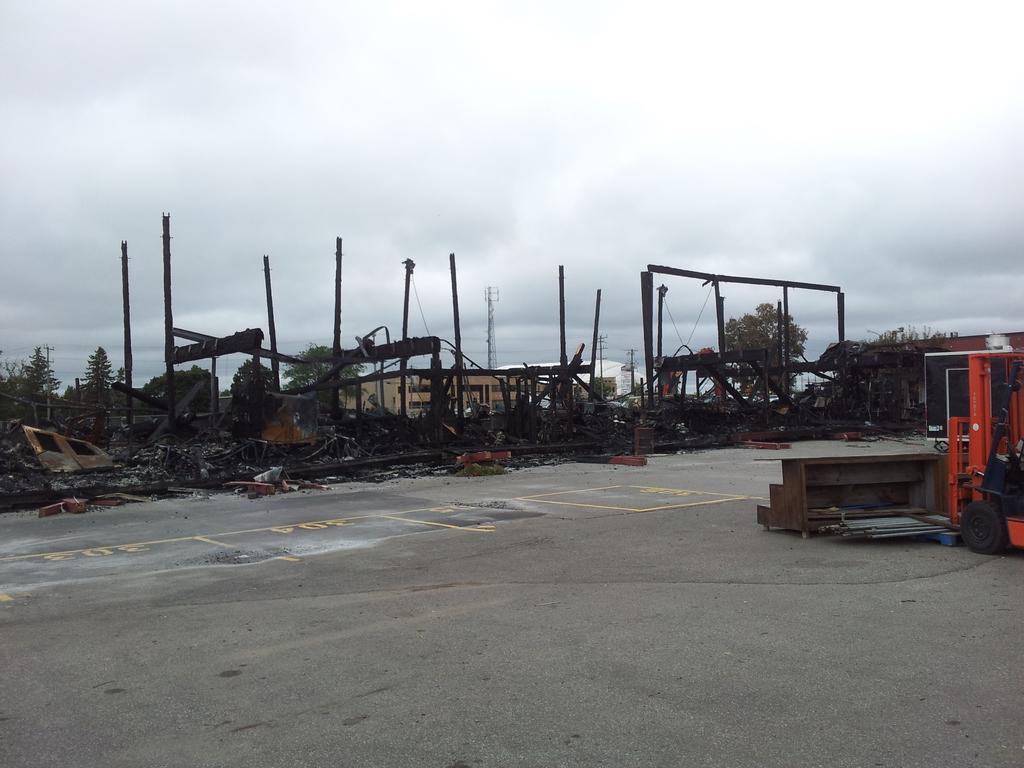In one or two sentences, can you explain what this image depicts? This image is taken outdoors. At the top of the image there is the sky with clouds. At the bottom of the image there is a road. On the right side of the image there is a wooden bench. There are a few things on the floor. In the background there are a few houses and there are two towers and poles with a few wires. There are a few trees and plants on the ground. In the middle of the image there is a scrap on the road and there are many Iron bars. 